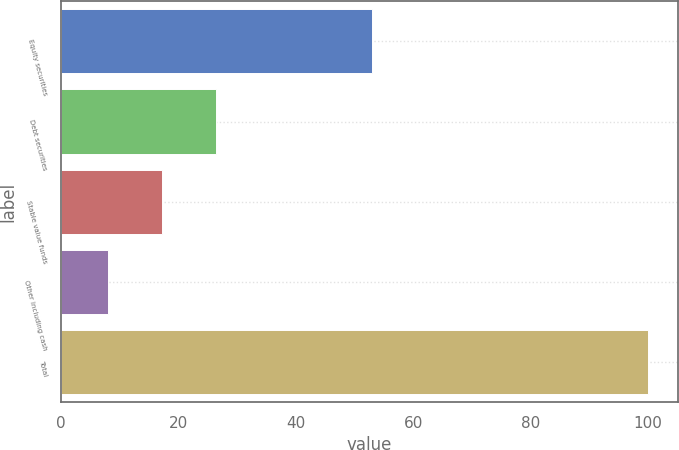<chart> <loc_0><loc_0><loc_500><loc_500><bar_chart><fcel>Equity securities<fcel>Debt securities<fcel>Stable value funds<fcel>Other including cash<fcel>Total<nl><fcel>53<fcel>26.4<fcel>17.2<fcel>8<fcel>100<nl></chart> 